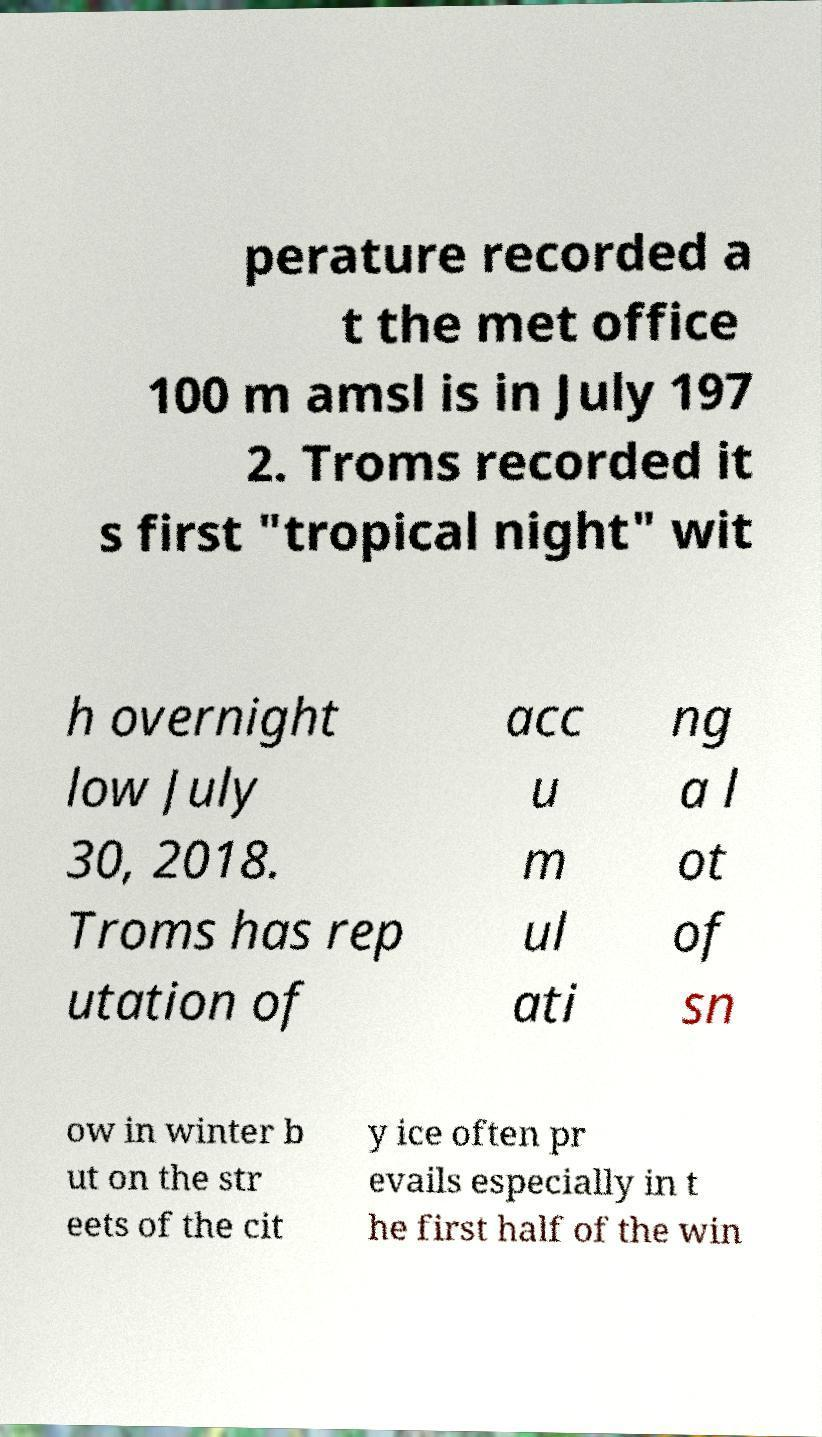Please read and relay the text visible in this image. What does it say? perature recorded a t the met office 100 m amsl is in July 197 2. Troms recorded it s first "tropical night" wit h overnight low July 30, 2018. Troms has rep utation of acc u m ul ati ng a l ot of sn ow in winter b ut on the str eets of the cit y ice often pr evails especially in t he first half of the win 